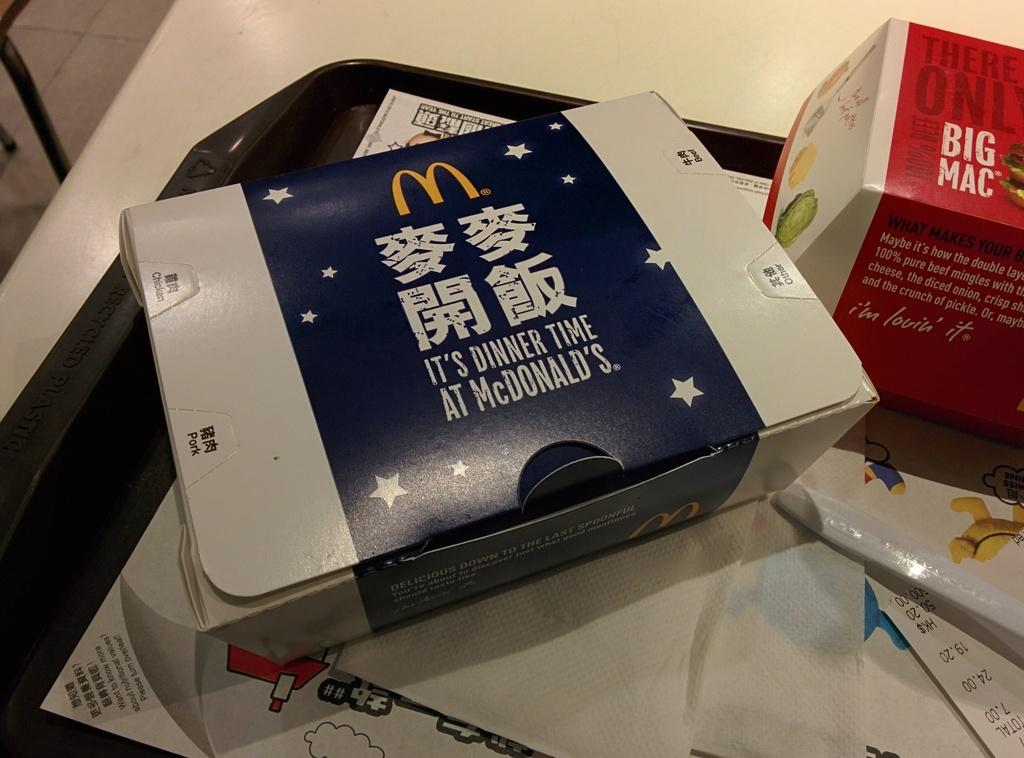<image>
Offer a succinct explanation of the picture presented. McDonalds containers with Big Mac written on the red and white one. 